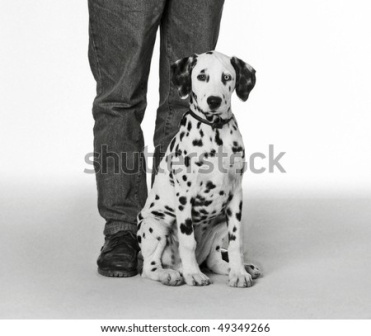Imagine a day in the life of this Dalmatian puppy. A typical day for this Dalmatian puppy, named Pongo, begins with a playful bark to wake up his owner. They start the morning with a brisk walk in the park, where Pongo loves chasing after squirrels and exploring the grassy fields. After returning home, Pongo eagerly stations himself by the kitchen, knowing breakfast is soon to come. The rest of the morning might be spent lounging by the window, sunbathing, or playing with his favorite chew toy. By afternoon, Pongo and his owner head out again, this time to the pet store to pick out a new toy. In the evening, Pongo sits by his owner’s feet, enjoying the comfort of being close while they unwind after a long day. Bedtime arrives, and Pongo curls up in his cozy dog bed, dreaming of tomorrow's adventures. 